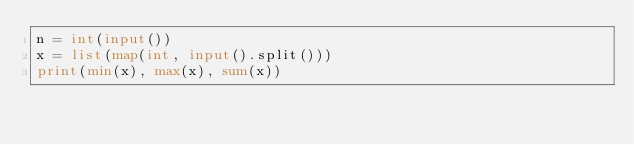Convert code to text. <code><loc_0><loc_0><loc_500><loc_500><_Python_>n = int(input())
x = list(map(int, input().split()))
print(min(x), max(x), sum(x))
</code> 